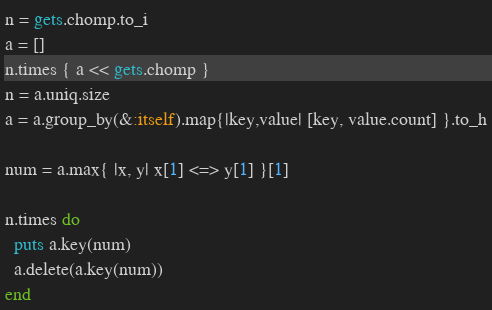Convert code to text. <code><loc_0><loc_0><loc_500><loc_500><_Ruby_>n = gets.chomp.to_i
a = []
n.times { a << gets.chomp }
n = a.uniq.size
a = a.group_by(&:itself).map{|key,value| [key, value.count] }.to_h
 
num = a.max{ |x, y| x[1] <=> y[1] }[1]
 
n.times do
  puts a.key(num)
  a.delete(a.key(num))
end
</code> 